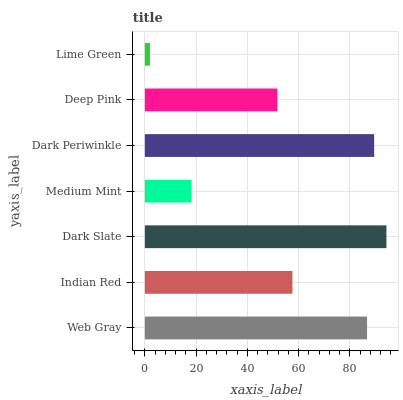Is Lime Green the minimum?
Answer yes or no. Yes. Is Dark Slate the maximum?
Answer yes or no. Yes. Is Indian Red the minimum?
Answer yes or no. No. Is Indian Red the maximum?
Answer yes or no. No. Is Web Gray greater than Indian Red?
Answer yes or no. Yes. Is Indian Red less than Web Gray?
Answer yes or no. Yes. Is Indian Red greater than Web Gray?
Answer yes or no. No. Is Web Gray less than Indian Red?
Answer yes or no. No. Is Indian Red the high median?
Answer yes or no. Yes. Is Indian Red the low median?
Answer yes or no. Yes. Is Dark Periwinkle the high median?
Answer yes or no. No. Is Medium Mint the low median?
Answer yes or no. No. 